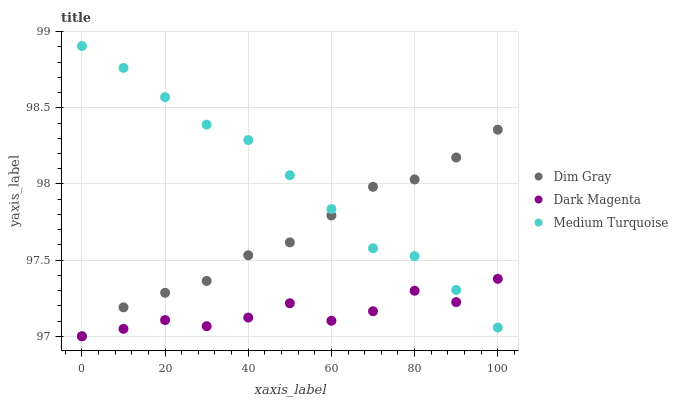Does Dark Magenta have the minimum area under the curve?
Answer yes or no. Yes. Does Medium Turquoise have the maximum area under the curve?
Answer yes or no. Yes. Does Medium Turquoise have the minimum area under the curve?
Answer yes or no. No. Does Dark Magenta have the maximum area under the curve?
Answer yes or no. No. Is Dim Gray the smoothest?
Answer yes or no. Yes. Is Dark Magenta the roughest?
Answer yes or no. Yes. Is Medium Turquoise the smoothest?
Answer yes or no. No. Is Medium Turquoise the roughest?
Answer yes or no. No. Does Dim Gray have the lowest value?
Answer yes or no. Yes. Does Medium Turquoise have the lowest value?
Answer yes or no. No. Does Medium Turquoise have the highest value?
Answer yes or no. Yes. Does Dark Magenta have the highest value?
Answer yes or no. No. Does Dim Gray intersect Medium Turquoise?
Answer yes or no. Yes. Is Dim Gray less than Medium Turquoise?
Answer yes or no. No. Is Dim Gray greater than Medium Turquoise?
Answer yes or no. No. 